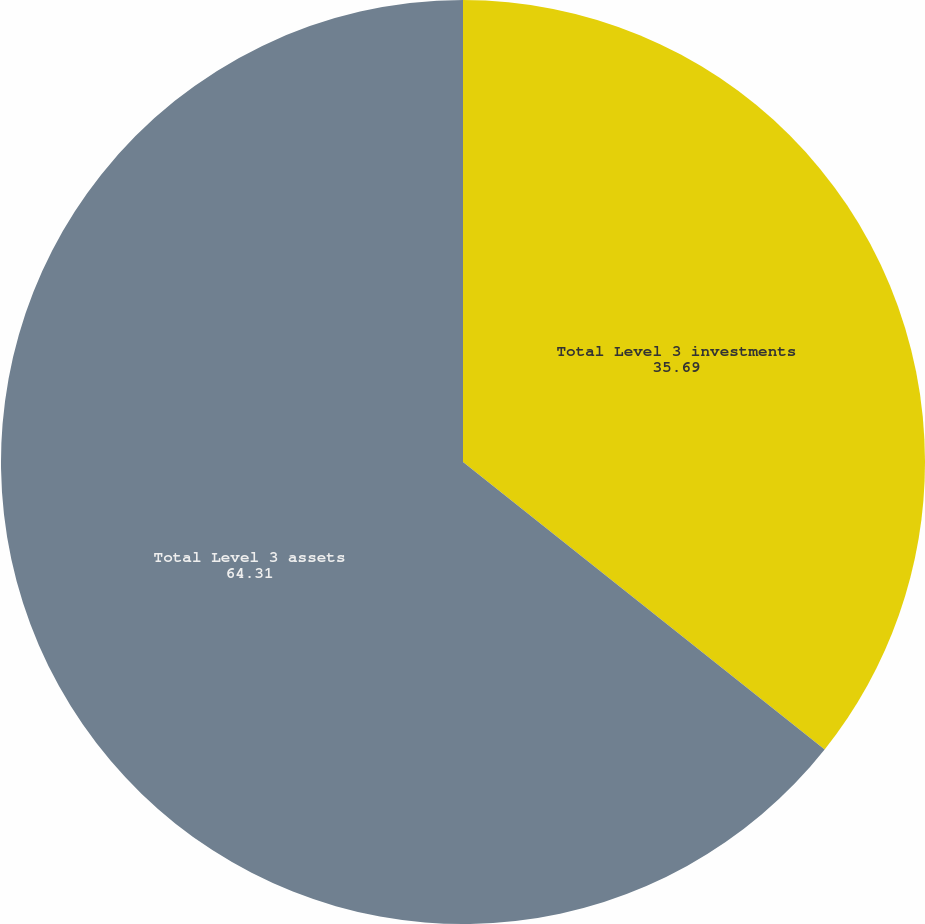Convert chart. <chart><loc_0><loc_0><loc_500><loc_500><pie_chart><fcel>Total Level 3 investments<fcel>Total Level 3 assets<nl><fcel>35.69%<fcel>64.31%<nl></chart> 